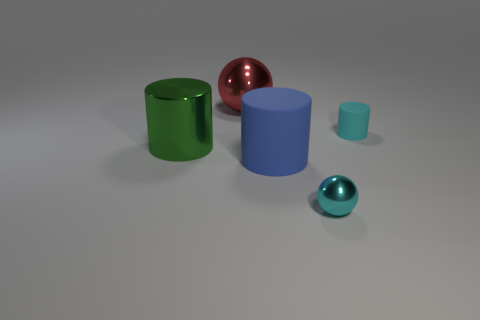Can you describe the lighting and shadows in the scene? The lighting in the scene is uniform and soft, creating gentle shadows on the ground plane that suggest an ambient light source, possibly overhead. The highlights on the objects indicate a diffused light environment with no harsh direct light, contributing to a calm and balanced atmosphere within the image. Does the lighting affect the perception of colors and materials? Yes, the soft lighting in the scene allows the true colors of the objects to be distinctly visible, enhancing the perception of their materials. Subtle shadows help to define the shapes and textures, providing depth and realism to the objects without distorting their colors. 